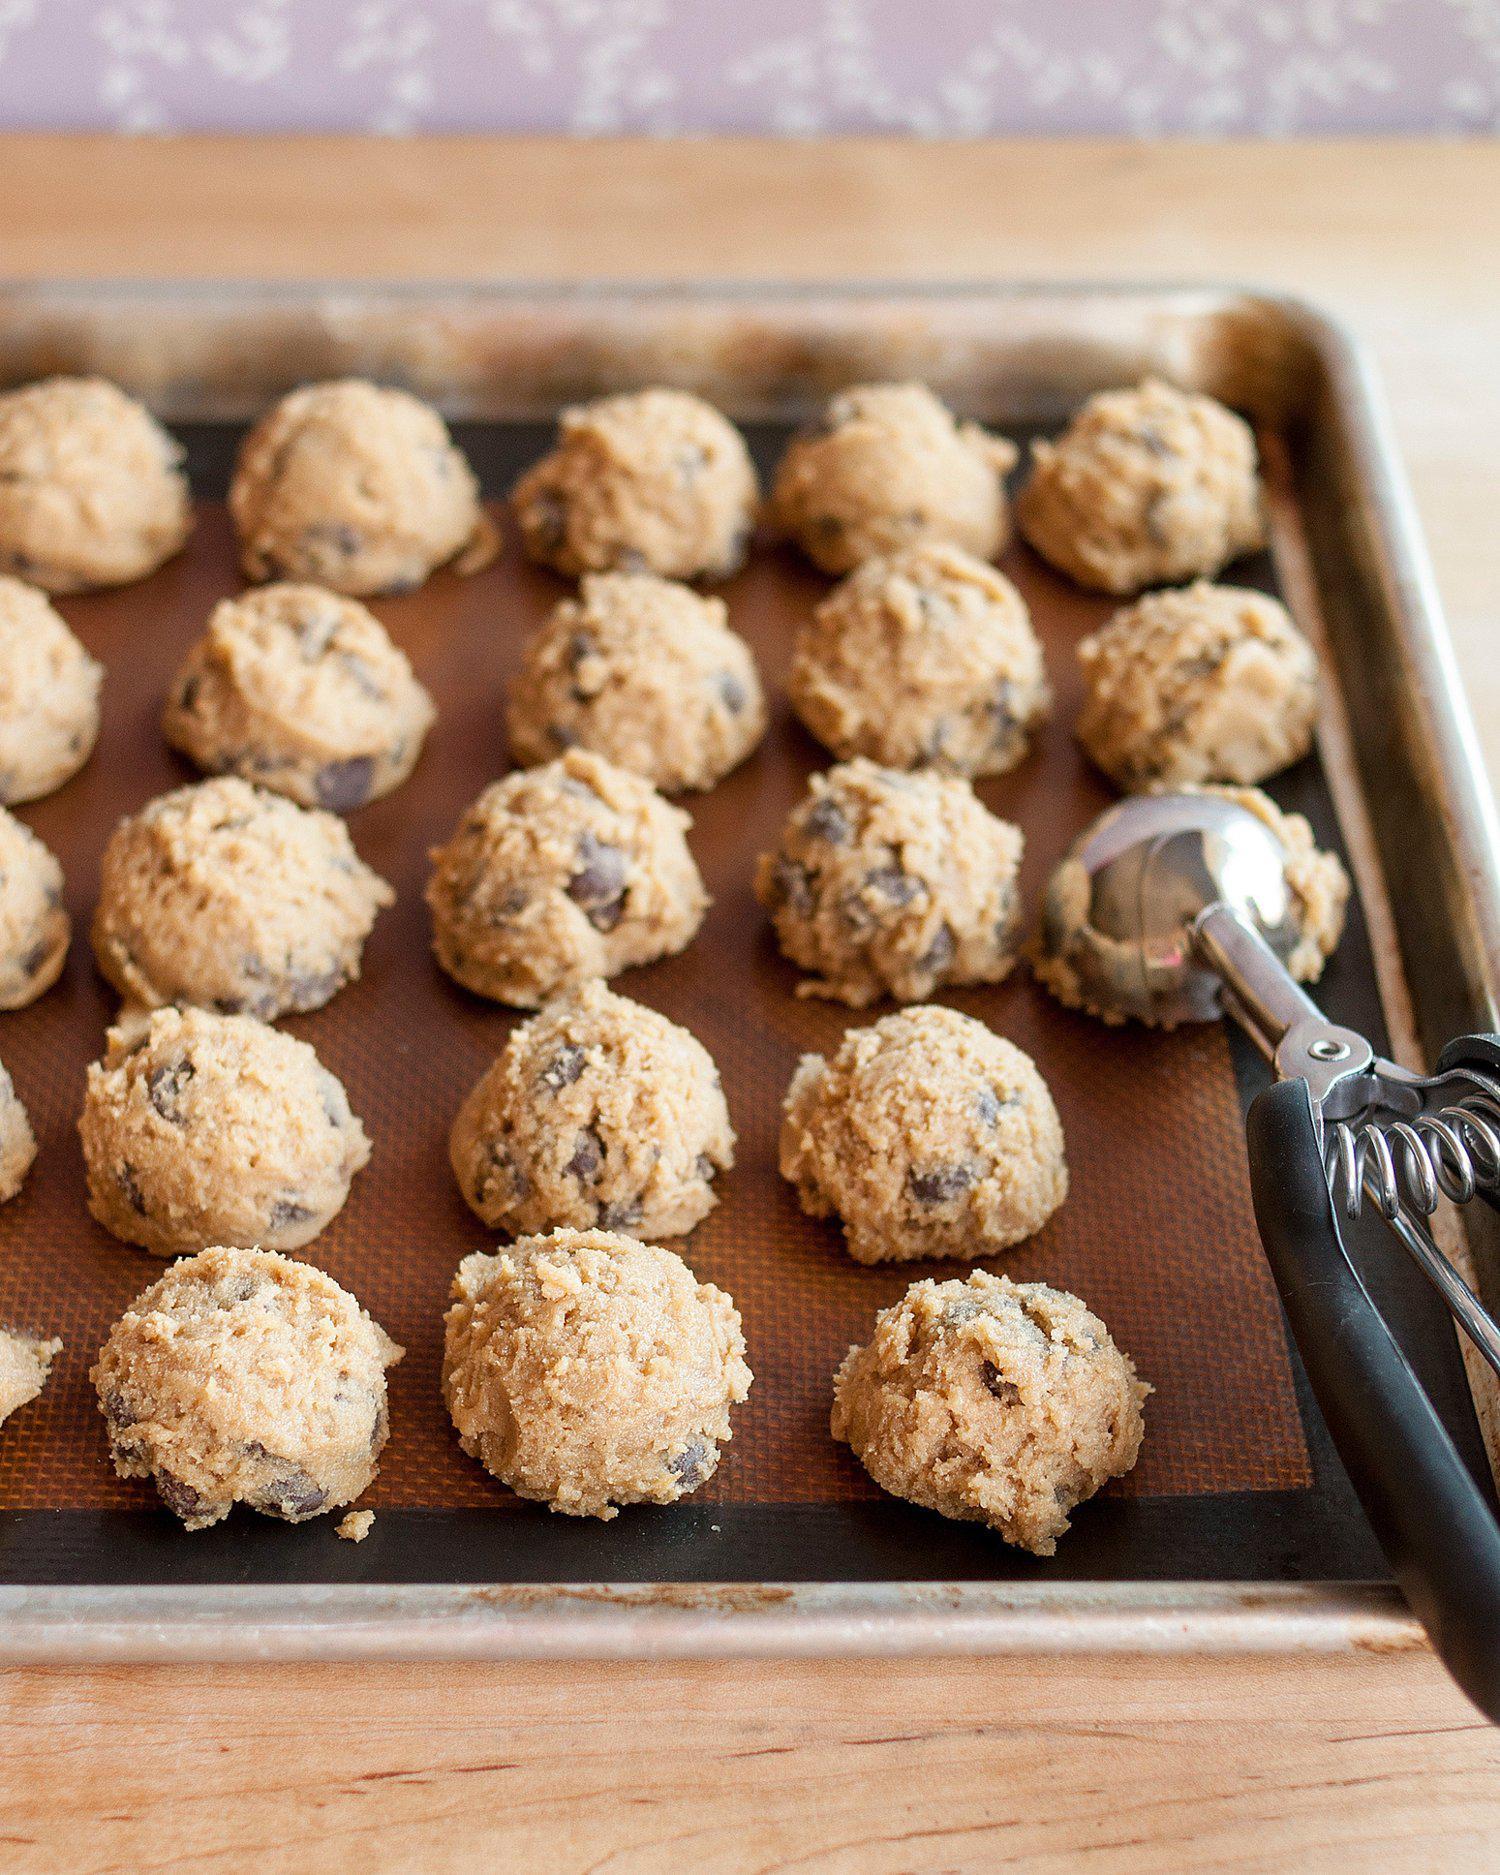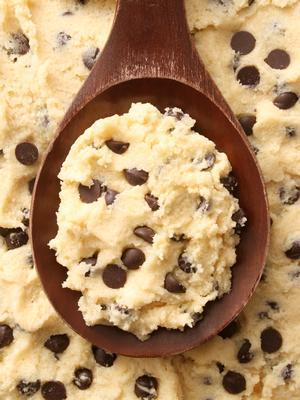The first image is the image on the left, the second image is the image on the right. Given the left and right images, does the statement "Some of the cookie dough is in balls neatly lined up." hold true? Answer yes or no. Yes. The first image is the image on the left, the second image is the image on the right. Analyze the images presented: Is the assertion "A utensil with a handle is touching raw chocolate chip cookie dough in at least one image." valid? Answer yes or no. Yes. 